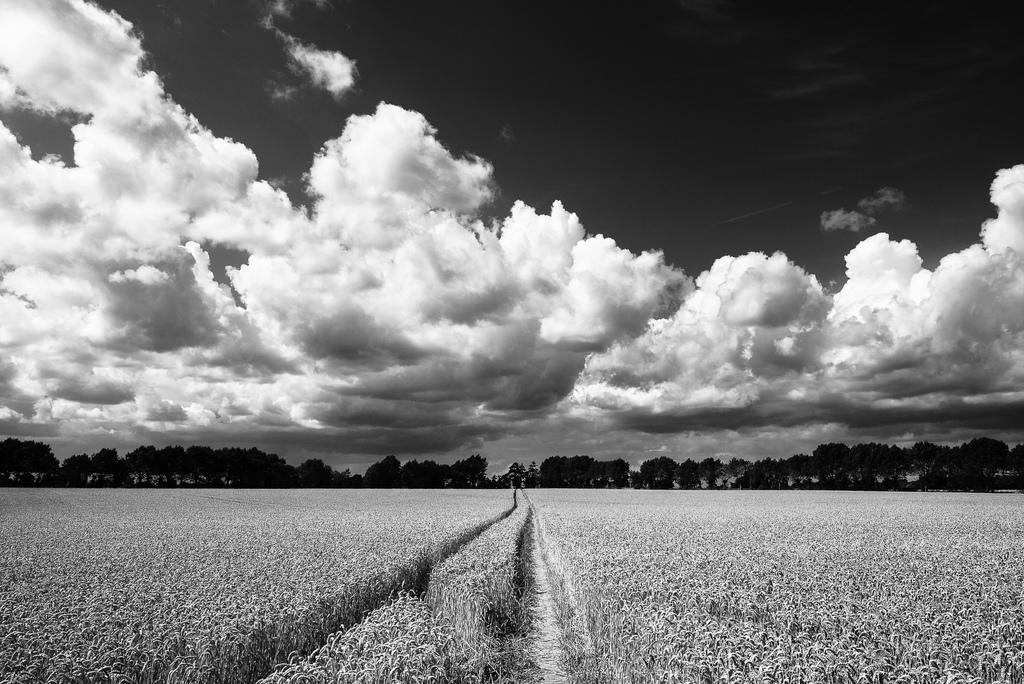Could you give a brief overview of what you see in this image? In this picture I can see the field in front and in the background I can see number of trees and I can see the cloudy sky. 